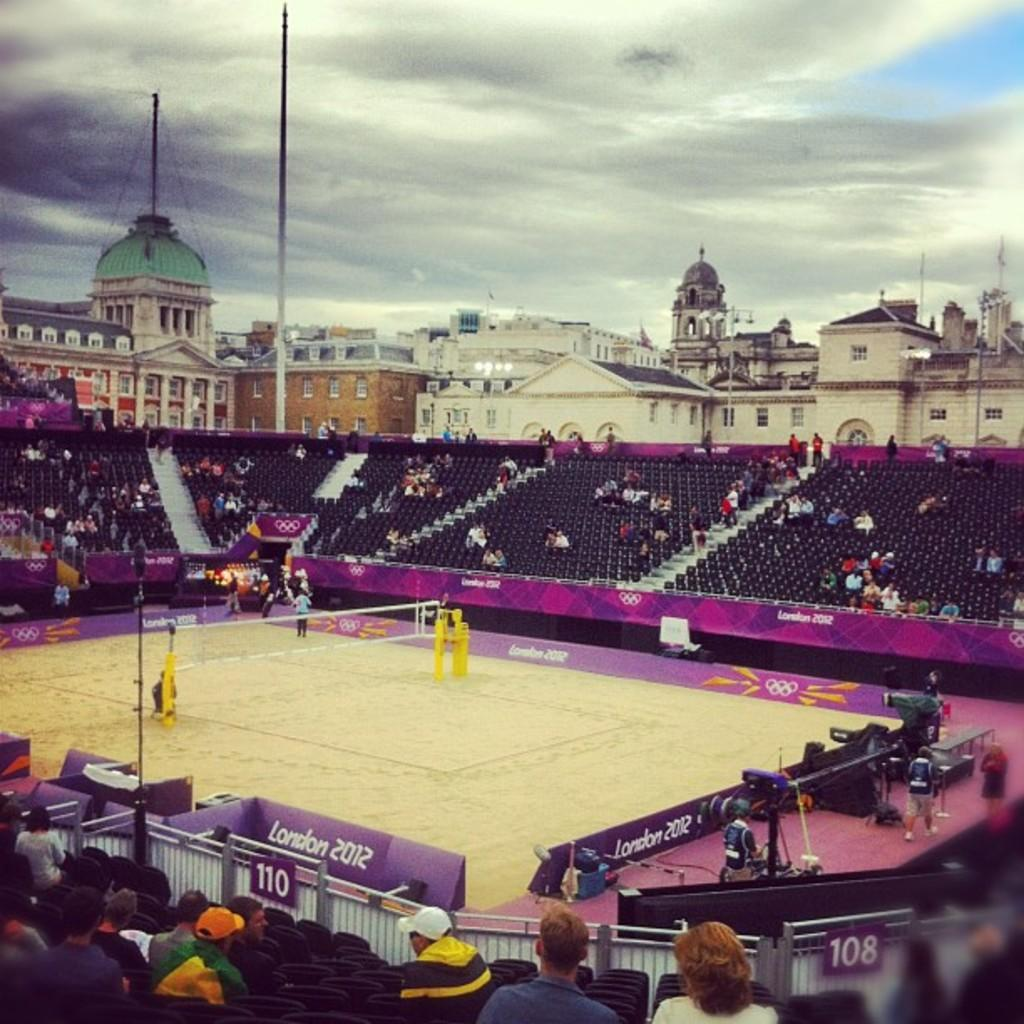What is the main subject in the foreground of the image? There is a tennis court in the foreground of the image. What can be seen in the background of the image? There is a stadium with a crowd in the background of the image. What types of structures are visible in the top part of the image? Buildings, poles, domes, and clouds are visible in the top part of the image. What is the sky's condition in the image? The sky is visible in the top part of the image. What scientific discovery is being celebrated by the crowd in the image? There is no indication of a scientific discovery being celebrated in the image; it features a tennis court and a stadium with a crowd. What type of engine is powering the poles in the image? There is no engine present in the image, as the poles are likely supporting lights or other equipment. 